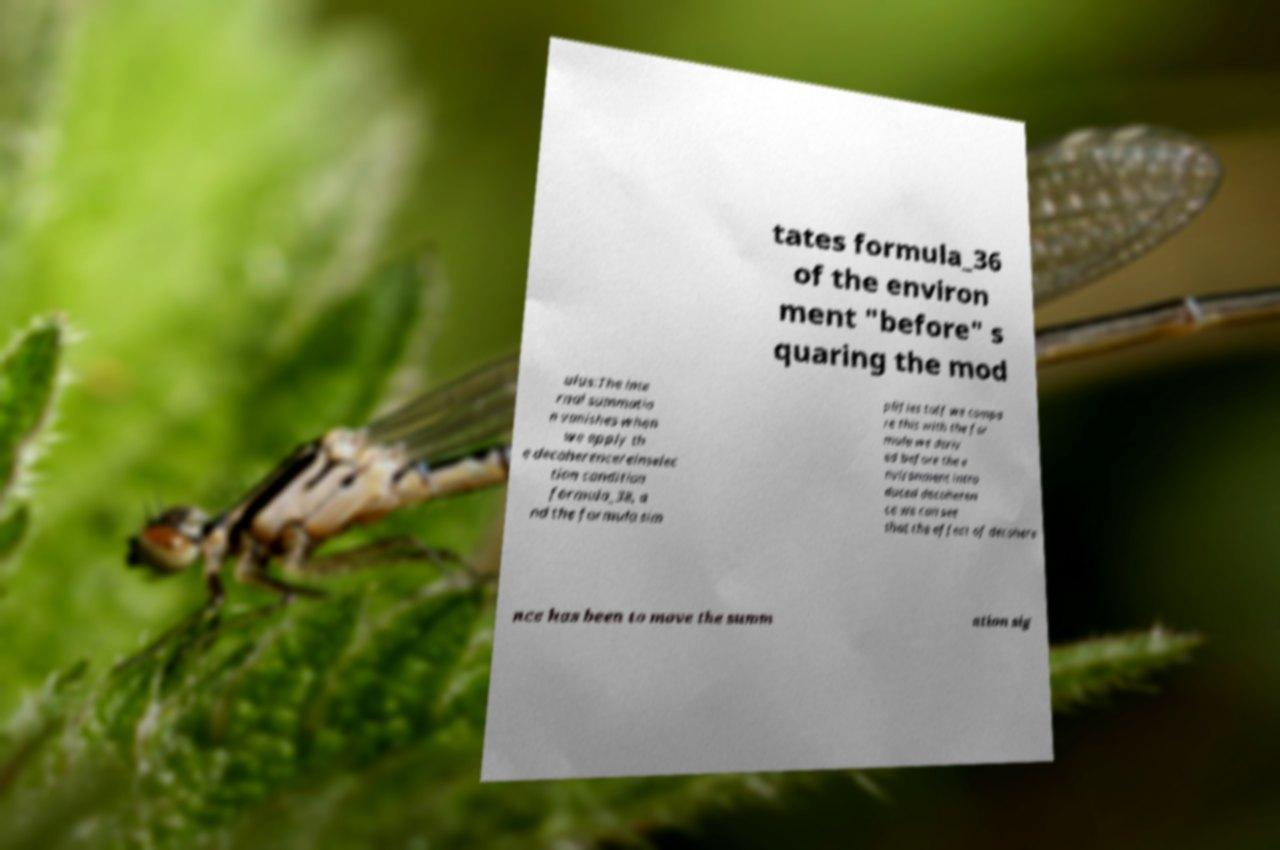There's text embedded in this image that I need extracted. Can you transcribe it verbatim? tates formula_36 of the environ ment "before" s quaring the mod ulus:The inte rnal summatio n vanishes when we apply th e decoherence/einselec tion condition formula_38, a nd the formula sim plifies toIf we compa re this with the for mula we deriv ed before the e nvironment intro duced decoheren ce we can see that the effect of decohere nce has been to move the summ ation sig 